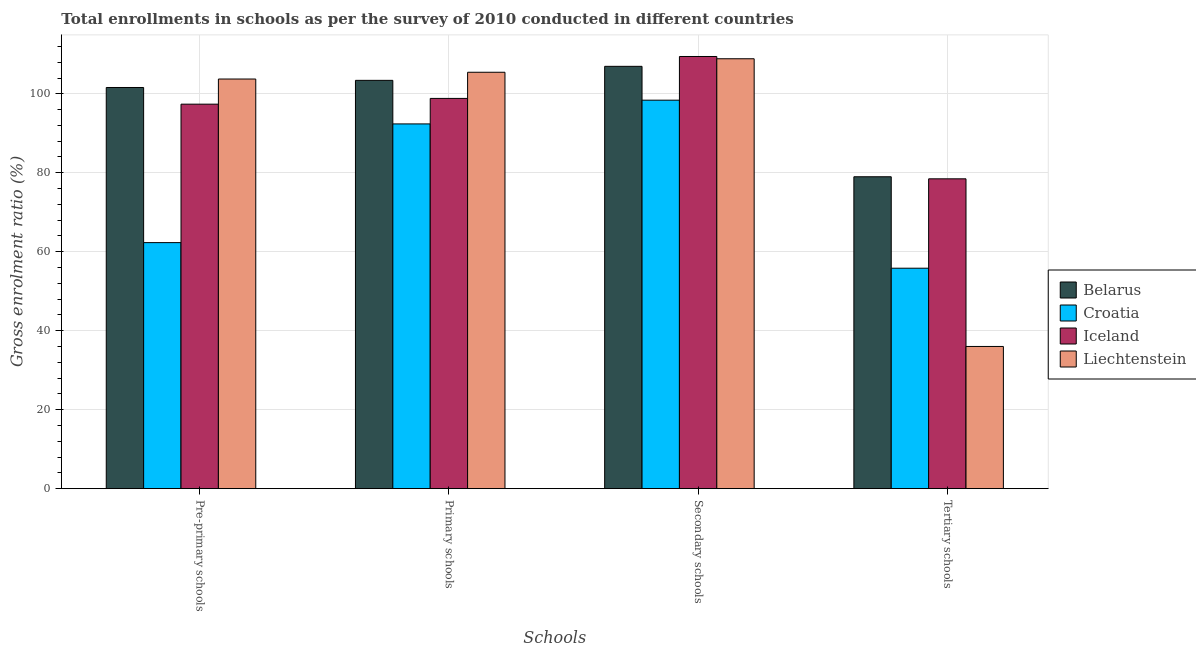Are the number of bars per tick equal to the number of legend labels?
Keep it short and to the point. Yes. Are the number of bars on each tick of the X-axis equal?
Give a very brief answer. Yes. How many bars are there on the 2nd tick from the left?
Make the answer very short. 4. What is the label of the 2nd group of bars from the left?
Give a very brief answer. Primary schools. What is the gross enrolment ratio in tertiary schools in Belarus?
Keep it short and to the point. 78.99. Across all countries, what is the maximum gross enrolment ratio in pre-primary schools?
Provide a short and direct response. 103.74. Across all countries, what is the minimum gross enrolment ratio in pre-primary schools?
Your response must be concise. 62.31. In which country was the gross enrolment ratio in primary schools maximum?
Ensure brevity in your answer.  Liechtenstein. In which country was the gross enrolment ratio in pre-primary schools minimum?
Offer a very short reply. Croatia. What is the total gross enrolment ratio in pre-primary schools in the graph?
Your answer should be compact. 365.04. What is the difference between the gross enrolment ratio in tertiary schools in Croatia and that in Belarus?
Your response must be concise. -23.16. What is the difference between the gross enrolment ratio in pre-primary schools in Croatia and the gross enrolment ratio in primary schools in Belarus?
Offer a terse response. -41.09. What is the average gross enrolment ratio in primary schools per country?
Give a very brief answer. 100.02. What is the difference between the gross enrolment ratio in secondary schools and gross enrolment ratio in pre-primary schools in Liechtenstein?
Offer a terse response. 5.13. What is the ratio of the gross enrolment ratio in pre-primary schools in Iceland to that in Croatia?
Offer a very short reply. 1.56. Is the difference between the gross enrolment ratio in secondary schools in Iceland and Liechtenstein greater than the difference between the gross enrolment ratio in primary schools in Iceland and Liechtenstein?
Offer a very short reply. Yes. What is the difference between the highest and the second highest gross enrolment ratio in tertiary schools?
Provide a succinct answer. 0.52. What is the difference between the highest and the lowest gross enrolment ratio in primary schools?
Offer a terse response. 13.08. In how many countries, is the gross enrolment ratio in primary schools greater than the average gross enrolment ratio in primary schools taken over all countries?
Offer a very short reply. 2. Is the sum of the gross enrolment ratio in primary schools in Belarus and Croatia greater than the maximum gross enrolment ratio in pre-primary schools across all countries?
Your answer should be compact. Yes. Is it the case that in every country, the sum of the gross enrolment ratio in secondary schools and gross enrolment ratio in primary schools is greater than the sum of gross enrolment ratio in pre-primary schools and gross enrolment ratio in tertiary schools?
Offer a terse response. No. What does the 1st bar from the left in Secondary schools represents?
Ensure brevity in your answer.  Belarus. How many bars are there?
Provide a succinct answer. 16. Are all the bars in the graph horizontal?
Offer a terse response. No. How many countries are there in the graph?
Ensure brevity in your answer.  4. Are the values on the major ticks of Y-axis written in scientific E-notation?
Your response must be concise. No. Does the graph contain grids?
Offer a very short reply. Yes. Where does the legend appear in the graph?
Keep it short and to the point. Center right. How many legend labels are there?
Offer a terse response. 4. How are the legend labels stacked?
Your answer should be compact. Vertical. What is the title of the graph?
Give a very brief answer. Total enrollments in schools as per the survey of 2010 conducted in different countries. Does "Latin America(all income levels)" appear as one of the legend labels in the graph?
Your response must be concise. No. What is the label or title of the X-axis?
Your response must be concise. Schools. What is the label or title of the Y-axis?
Ensure brevity in your answer.  Gross enrolment ratio (%). What is the Gross enrolment ratio (%) in Belarus in Pre-primary schools?
Offer a very short reply. 101.6. What is the Gross enrolment ratio (%) in Croatia in Pre-primary schools?
Provide a succinct answer. 62.31. What is the Gross enrolment ratio (%) in Iceland in Pre-primary schools?
Make the answer very short. 97.38. What is the Gross enrolment ratio (%) in Liechtenstein in Pre-primary schools?
Make the answer very short. 103.74. What is the Gross enrolment ratio (%) in Belarus in Primary schools?
Your response must be concise. 103.41. What is the Gross enrolment ratio (%) in Croatia in Primary schools?
Your answer should be compact. 92.38. What is the Gross enrolment ratio (%) in Iceland in Primary schools?
Your answer should be compact. 98.84. What is the Gross enrolment ratio (%) in Liechtenstein in Primary schools?
Offer a terse response. 105.46. What is the Gross enrolment ratio (%) in Belarus in Secondary schools?
Give a very brief answer. 106.96. What is the Gross enrolment ratio (%) of Croatia in Secondary schools?
Ensure brevity in your answer.  98.39. What is the Gross enrolment ratio (%) of Iceland in Secondary schools?
Make the answer very short. 109.45. What is the Gross enrolment ratio (%) in Liechtenstein in Secondary schools?
Offer a very short reply. 108.88. What is the Gross enrolment ratio (%) in Belarus in Tertiary schools?
Keep it short and to the point. 78.99. What is the Gross enrolment ratio (%) in Croatia in Tertiary schools?
Provide a succinct answer. 55.83. What is the Gross enrolment ratio (%) in Iceland in Tertiary schools?
Your response must be concise. 78.47. What is the Gross enrolment ratio (%) in Liechtenstein in Tertiary schools?
Offer a terse response. 36.02. Across all Schools, what is the maximum Gross enrolment ratio (%) in Belarus?
Your answer should be compact. 106.96. Across all Schools, what is the maximum Gross enrolment ratio (%) of Croatia?
Ensure brevity in your answer.  98.39. Across all Schools, what is the maximum Gross enrolment ratio (%) of Iceland?
Make the answer very short. 109.45. Across all Schools, what is the maximum Gross enrolment ratio (%) in Liechtenstein?
Your answer should be compact. 108.88. Across all Schools, what is the minimum Gross enrolment ratio (%) of Belarus?
Make the answer very short. 78.99. Across all Schools, what is the minimum Gross enrolment ratio (%) in Croatia?
Keep it short and to the point. 55.83. Across all Schools, what is the minimum Gross enrolment ratio (%) in Iceland?
Provide a succinct answer. 78.47. Across all Schools, what is the minimum Gross enrolment ratio (%) of Liechtenstein?
Provide a succinct answer. 36.02. What is the total Gross enrolment ratio (%) in Belarus in the graph?
Ensure brevity in your answer.  390.96. What is the total Gross enrolment ratio (%) of Croatia in the graph?
Ensure brevity in your answer.  308.91. What is the total Gross enrolment ratio (%) of Iceland in the graph?
Your response must be concise. 384.14. What is the total Gross enrolment ratio (%) of Liechtenstein in the graph?
Your response must be concise. 354.1. What is the difference between the Gross enrolment ratio (%) in Belarus in Pre-primary schools and that in Primary schools?
Offer a terse response. -1.81. What is the difference between the Gross enrolment ratio (%) of Croatia in Pre-primary schools and that in Primary schools?
Your response must be concise. -30.06. What is the difference between the Gross enrolment ratio (%) of Iceland in Pre-primary schools and that in Primary schools?
Make the answer very short. -1.46. What is the difference between the Gross enrolment ratio (%) of Liechtenstein in Pre-primary schools and that in Primary schools?
Your response must be concise. -1.71. What is the difference between the Gross enrolment ratio (%) of Belarus in Pre-primary schools and that in Secondary schools?
Provide a succinct answer. -5.36. What is the difference between the Gross enrolment ratio (%) of Croatia in Pre-primary schools and that in Secondary schools?
Your answer should be compact. -36.07. What is the difference between the Gross enrolment ratio (%) in Iceland in Pre-primary schools and that in Secondary schools?
Provide a succinct answer. -12.08. What is the difference between the Gross enrolment ratio (%) in Liechtenstein in Pre-primary schools and that in Secondary schools?
Give a very brief answer. -5.13. What is the difference between the Gross enrolment ratio (%) in Belarus in Pre-primary schools and that in Tertiary schools?
Provide a succinct answer. 22.61. What is the difference between the Gross enrolment ratio (%) of Croatia in Pre-primary schools and that in Tertiary schools?
Your response must be concise. 6.48. What is the difference between the Gross enrolment ratio (%) of Iceland in Pre-primary schools and that in Tertiary schools?
Your response must be concise. 18.91. What is the difference between the Gross enrolment ratio (%) in Liechtenstein in Pre-primary schools and that in Tertiary schools?
Provide a succinct answer. 67.73. What is the difference between the Gross enrolment ratio (%) of Belarus in Primary schools and that in Secondary schools?
Give a very brief answer. -3.55. What is the difference between the Gross enrolment ratio (%) in Croatia in Primary schools and that in Secondary schools?
Offer a very short reply. -6.01. What is the difference between the Gross enrolment ratio (%) of Iceland in Primary schools and that in Secondary schools?
Make the answer very short. -10.62. What is the difference between the Gross enrolment ratio (%) in Liechtenstein in Primary schools and that in Secondary schools?
Offer a terse response. -3.42. What is the difference between the Gross enrolment ratio (%) in Belarus in Primary schools and that in Tertiary schools?
Your answer should be compact. 24.41. What is the difference between the Gross enrolment ratio (%) of Croatia in Primary schools and that in Tertiary schools?
Offer a very short reply. 36.54. What is the difference between the Gross enrolment ratio (%) of Iceland in Primary schools and that in Tertiary schools?
Your answer should be compact. 20.36. What is the difference between the Gross enrolment ratio (%) in Liechtenstein in Primary schools and that in Tertiary schools?
Your response must be concise. 69.44. What is the difference between the Gross enrolment ratio (%) of Belarus in Secondary schools and that in Tertiary schools?
Make the answer very short. 27.97. What is the difference between the Gross enrolment ratio (%) of Croatia in Secondary schools and that in Tertiary schools?
Offer a very short reply. 42.55. What is the difference between the Gross enrolment ratio (%) of Iceland in Secondary schools and that in Tertiary schools?
Offer a terse response. 30.98. What is the difference between the Gross enrolment ratio (%) of Liechtenstein in Secondary schools and that in Tertiary schools?
Offer a terse response. 72.86. What is the difference between the Gross enrolment ratio (%) in Belarus in Pre-primary schools and the Gross enrolment ratio (%) in Croatia in Primary schools?
Your response must be concise. 9.22. What is the difference between the Gross enrolment ratio (%) in Belarus in Pre-primary schools and the Gross enrolment ratio (%) in Iceland in Primary schools?
Your answer should be very brief. 2.76. What is the difference between the Gross enrolment ratio (%) in Belarus in Pre-primary schools and the Gross enrolment ratio (%) in Liechtenstein in Primary schools?
Offer a terse response. -3.86. What is the difference between the Gross enrolment ratio (%) of Croatia in Pre-primary schools and the Gross enrolment ratio (%) of Iceland in Primary schools?
Offer a very short reply. -36.52. What is the difference between the Gross enrolment ratio (%) of Croatia in Pre-primary schools and the Gross enrolment ratio (%) of Liechtenstein in Primary schools?
Keep it short and to the point. -43.15. What is the difference between the Gross enrolment ratio (%) of Iceland in Pre-primary schools and the Gross enrolment ratio (%) of Liechtenstein in Primary schools?
Ensure brevity in your answer.  -8.08. What is the difference between the Gross enrolment ratio (%) of Belarus in Pre-primary schools and the Gross enrolment ratio (%) of Croatia in Secondary schools?
Keep it short and to the point. 3.21. What is the difference between the Gross enrolment ratio (%) in Belarus in Pre-primary schools and the Gross enrolment ratio (%) in Iceland in Secondary schools?
Your response must be concise. -7.85. What is the difference between the Gross enrolment ratio (%) of Belarus in Pre-primary schools and the Gross enrolment ratio (%) of Liechtenstein in Secondary schools?
Keep it short and to the point. -7.28. What is the difference between the Gross enrolment ratio (%) in Croatia in Pre-primary schools and the Gross enrolment ratio (%) in Iceland in Secondary schools?
Your response must be concise. -47.14. What is the difference between the Gross enrolment ratio (%) in Croatia in Pre-primary schools and the Gross enrolment ratio (%) in Liechtenstein in Secondary schools?
Ensure brevity in your answer.  -46.57. What is the difference between the Gross enrolment ratio (%) of Iceland in Pre-primary schools and the Gross enrolment ratio (%) of Liechtenstein in Secondary schools?
Provide a short and direct response. -11.5. What is the difference between the Gross enrolment ratio (%) of Belarus in Pre-primary schools and the Gross enrolment ratio (%) of Croatia in Tertiary schools?
Your response must be concise. 45.77. What is the difference between the Gross enrolment ratio (%) in Belarus in Pre-primary schools and the Gross enrolment ratio (%) in Iceland in Tertiary schools?
Keep it short and to the point. 23.13. What is the difference between the Gross enrolment ratio (%) of Belarus in Pre-primary schools and the Gross enrolment ratio (%) of Liechtenstein in Tertiary schools?
Ensure brevity in your answer.  65.58. What is the difference between the Gross enrolment ratio (%) in Croatia in Pre-primary schools and the Gross enrolment ratio (%) in Iceland in Tertiary schools?
Offer a terse response. -16.16. What is the difference between the Gross enrolment ratio (%) in Croatia in Pre-primary schools and the Gross enrolment ratio (%) in Liechtenstein in Tertiary schools?
Make the answer very short. 26.3. What is the difference between the Gross enrolment ratio (%) of Iceland in Pre-primary schools and the Gross enrolment ratio (%) of Liechtenstein in Tertiary schools?
Your answer should be very brief. 61.36. What is the difference between the Gross enrolment ratio (%) of Belarus in Primary schools and the Gross enrolment ratio (%) of Croatia in Secondary schools?
Make the answer very short. 5.02. What is the difference between the Gross enrolment ratio (%) in Belarus in Primary schools and the Gross enrolment ratio (%) in Iceland in Secondary schools?
Give a very brief answer. -6.05. What is the difference between the Gross enrolment ratio (%) in Belarus in Primary schools and the Gross enrolment ratio (%) in Liechtenstein in Secondary schools?
Keep it short and to the point. -5.47. What is the difference between the Gross enrolment ratio (%) of Croatia in Primary schools and the Gross enrolment ratio (%) of Iceland in Secondary schools?
Offer a terse response. -17.08. What is the difference between the Gross enrolment ratio (%) in Croatia in Primary schools and the Gross enrolment ratio (%) in Liechtenstein in Secondary schools?
Your answer should be very brief. -16.5. What is the difference between the Gross enrolment ratio (%) in Iceland in Primary schools and the Gross enrolment ratio (%) in Liechtenstein in Secondary schools?
Give a very brief answer. -10.04. What is the difference between the Gross enrolment ratio (%) of Belarus in Primary schools and the Gross enrolment ratio (%) of Croatia in Tertiary schools?
Your answer should be very brief. 47.57. What is the difference between the Gross enrolment ratio (%) of Belarus in Primary schools and the Gross enrolment ratio (%) of Iceland in Tertiary schools?
Offer a very short reply. 24.94. What is the difference between the Gross enrolment ratio (%) of Belarus in Primary schools and the Gross enrolment ratio (%) of Liechtenstein in Tertiary schools?
Make the answer very short. 67.39. What is the difference between the Gross enrolment ratio (%) in Croatia in Primary schools and the Gross enrolment ratio (%) in Iceland in Tertiary schools?
Offer a terse response. 13.9. What is the difference between the Gross enrolment ratio (%) of Croatia in Primary schools and the Gross enrolment ratio (%) of Liechtenstein in Tertiary schools?
Your answer should be compact. 56.36. What is the difference between the Gross enrolment ratio (%) of Iceland in Primary schools and the Gross enrolment ratio (%) of Liechtenstein in Tertiary schools?
Make the answer very short. 62.82. What is the difference between the Gross enrolment ratio (%) in Belarus in Secondary schools and the Gross enrolment ratio (%) in Croatia in Tertiary schools?
Provide a succinct answer. 51.13. What is the difference between the Gross enrolment ratio (%) of Belarus in Secondary schools and the Gross enrolment ratio (%) of Iceland in Tertiary schools?
Your answer should be compact. 28.49. What is the difference between the Gross enrolment ratio (%) of Belarus in Secondary schools and the Gross enrolment ratio (%) of Liechtenstein in Tertiary schools?
Keep it short and to the point. 70.94. What is the difference between the Gross enrolment ratio (%) in Croatia in Secondary schools and the Gross enrolment ratio (%) in Iceland in Tertiary schools?
Your answer should be compact. 19.92. What is the difference between the Gross enrolment ratio (%) of Croatia in Secondary schools and the Gross enrolment ratio (%) of Liechtenstein in Tertiary schools?
Your answer should be very brief. 62.37. What is the difference between the Gross enrolment ratio (%) of Iceland in Secondary schools and the Gross enrolment ratio (%) of Liechtenstein in Tertiary schools?
Your answer should be very brief. 73.44. What is the average Gross enrolment ratio (%) in Belarus per Schools?
Your answer should be compact. 97.74. What is the average Gross enrolment ratio (%) of Croatia per Schools?
Make the answer very short. 77.23. What is the average Gross enrolment ratio (%) of Iceland per Schools?
Provide a short and direct response. 96.04. What is the average Gross enrolment ratio (%) of Liechtenstein per Schools?
Offer a terse response. 88.53. What is the difference between the Gross enrolment ratio (%) in Belarus and Gross enrolment ratio (%) in Croatia in Pre-primary schools?
Offer a terse response. 39.29. What is the difference between the Gross enrolment ratio (%) in Belarus and Gross enrolment ratio (%) in Iceland in Pre-primary schools?
Make the answer very short. 4.22. What is the difference between the Gross enrolment ratio (%) of Belarus and Gross enrolment ratio (%) of Liechtenstein in Pre-primary schools?
Your response must be concise. -2.14. What is the difference between the Gross enrolment ratio (%) in Croatia and Gross enrolment ratio (%) in Iceland in Pre-primary schools?
Offer a very short reply. -35.06. What is the difference between the Gross enrolment ratio (%) in Croatia and Gross enrolment ratio (%) in Liechtenstein in Pre-primary schools?
Your answer should be very brief. -41.43. What is the difference between the Gross enrolment ratio (%) in Iceland and Gross enrolment ratio (%) in Liechtenstein in Pre-primary schools?
Provide a succinct answer. -6.37. What is the difference between the Gross enrolment ratio (%) in Belarus and Gross enrolment ratio (%) in Croatia in Primary schools?
Offer a very short reply. 11.03. What is the difference between the Gross enrolment ratio (%) of Belarus and Gross enrolment ratio (%) of Iceland in Primary schools?
Offer a very short reply. 4.57. What is the difference between the Gross enrolment ratio (%) in Belarus and Gross enrolment ratio (%) in Liechtenstein in Primary schools?
Your response must be concise. -2.05. What is the difference between the Gross enrolment ratio (%) of Croatia and Gross enrolment ratio (%) of Iceland in Primary schools?
Provide a short and direct response. -6.46. What is the difference between the Gross enrolment ratio (%) of Croatia and Gross enrolment ratio (%) of Liechtenstein in Primary schools?
Provide a short and direct response. -13.08. What is the difference between the Gross enrolment ratio (%) of Iceland and Gross enrolment ratio (%) of Liechtenstein in Primary schools?
Your answer should be compact. -6.62. What is the difference between the Gross enrolment ratio (%) in Belarus and Gross enrolment ratio (%) in Croatia in Secondary schools?
Your answer should be very brief. 8.57. What is the difference between the Gross enrolment ratio (%) of Belarus and Gross enrolment ratio (%) of Iceland in Secondary schools?
Give a very brief answer. -2.49. What is the difference between the Gross enrolment ratio (%) of Belarus and Gross enrolment ratio (%) of Liechtenstein in Secondary schools?
Offer a terse response. -1.92. What is the difference between the Gross enrolment ratio (%) of Croatia and Gross enrolment ratio (%) of Iceland in Secondary schools?
Your answer should be very brief. -11.07. What is the difference between the Gross enrolment ratio (%) in Croatia and Gross enrolment ratio (%) in Liechtenstein in Secondary schools?
Ensure brevity in your answer.  -10.49. What is the difference between the Gross enrolment ratio (%) in Iceland and Gross enrolment ratio (%) in Liechtenstein in Secondary schools?
Offer a very short reply. 0.57. What is the difference between the Gross enrolment ratio (%) in Belarus and Gross enrolment ratio (%) in Croatia in Tertiary schools?
Keep it short and to the point. 23.16. What is the difference between the Gross enrolment ratio (%) of Belarus and Gross enrolment ratio (%) of Iceland in Tertiary schools?
Your answer should be very brief. 0.52. What is the difference between the Gross enrolment ratio (%) of Belarus and Gross enrolment ratio (%) of Liechtenstein in Tertiary schools?
Your answer should be compact. 42.98. What is the difference between the Gross enrolment ratio (%) in Croatia and Gross enrolment ratio (%) in Iceland in Tertiary schools?
Offer a terse response. -22.64. What is the difference between the Gross enrolment ratio (%) of Croatia and Gross enrolment ratio (%) of Liechtenstein in Tertiary schools?
Provide a short and direct response. 19.82. What is the difference between the Gross enrolment ratio (%) of Iceland and Gross enrolment ratio (%) of Liechtenstein in Tertiary schools?
Your answer should be very brief. 42.45. What is the ratio of the Gross enrolment ratio (%) of Belarus in Pre-primary schools to that in Primary schools?
Provide a succinct answer. 0.98. What is the ratio of the Gross enrolment ratio (%) of Croatia in Pre-primary schools to that in Primary schools?
Make the answer very short. 0.67. What is the ratio of the Gross enrolment ratio (%) in Iceland in Pre-primary schools to that in Primary schools?
Keep it short and to the point. 0.99. What is the ratio of the Gross enrolment ratio (%) of Liechtenstein in Pre-primary schools to that in Primary schools?
Your answer should be compact. 0.98. What is the ratio of the Gross enrolment ratio (%) of Belarus in Pre-primary schools to that in Secondary schools?
Give a very brief answer. 0.95. What is the ratio of the Gross enrolment ratio (%) in Croatia in Pre-primary schools to that in Secondary schools?
Provide a short and direct response. 0.63. What is the ratio of the Gross enrolment ratio (%) of Iceland in Pre-primary schools to that in Secondary schools?
Offer a very short reply. 0.89. What is the ratio of the Gross enrolment ratio (%) in Liechtenstein in Pre-primary schools to that in Secondary schools?
Offer a very short reply. 0.95. What is the ratio of the Gross enrolment ratio (%) in Belarus in Pre-primary schools to that in Tertiary schools?
Your answer should be compact. 1.29. What is the ratio of the Gross enrolment ratio (%) of Croatia in Pre-primary schools to that in Tertiary schools?
Give a very brief answer. 1.12. What is the ratio of the Gross enrolment ratio (%) of Iceland in Pre-primary schools to that in Tertiary schools?
Offer a very short reply. 1.24. What is the ratio of the Gross enrolment ratio (%) of Liechtenstein in Pre-primary schools to that in Tertiary schools?
Provide a succinct answer. 2.88. What is the ratio of the Gross enrolment ratio (%) of Belarus in Primary schools to that in Secondary schools?
Make the answer very short. 0.97. What is the ratio of the Gross enrolment ratio (%) in Croatia in Primary schools to that in Secondary schools?
Provide a short and direct response. 0.94. What is the ratio of the Gross enrolment ratio (%) in Iceland in Primary schools to that in Secondary schools?
Keep it short and to the point. 0.9. What is the ratio of the Gross enrolment ratio (%) of Liechtenstein in Primary schools to that in Secondary schools?
Give a very brief answer. 0.97. What is the ratio of the Gross enrolment ratio (%) in Belarus in Primary schools to that in Tertiary schools?
Provide a succinct answer. 1.31. What is the ratio of the Gross enrolment ratio (%) of Croatia in Primary schools to that in Tertiary schools?
Offer a terse response. 1.65. What is the ratio of the Gross enrolment ratio (%) in Iceland in Primary schools to that in Tertiary schools?
Offer a terse response. 1.26. What is the ratio of the Gross enrolment ratio (%) in Liechtenstein in Primary schools to that in Tertiary schools?
Provide a succinct answer. 2.93. What is the ratio of the Gross enrolment ratio (%) in Belarus in Secondary schools to that in Tertiary schools?
Provide a succinct answer. 1.35. What is the ratio of the Gross enrolment ratio (%) of Croatia in Secondary schools to that in Tertiary schools?
Your response must be concise. 1.76. What is the ratio of the Gross enrolment ratio (%) of Iceland in Secondary schools to that in Tertiary schools?
Ensure brevity in your answer.  1.39. What is the ratio of the Gross enrolment ratio (%) in Liechtenstein in Secondary schools to that in Tertiary schools?
Ensure brevity in your answer.  3.02. What is the difference between the highest and the second highest Gross enrolment ratio (%) in Belarus?
Your answer should be compact. 3.55. What is the difference between the highest and the second highest Gross enrolment ratio (%) in Croatia?
Your answer should be compact. 6.01. What is the difference between the highest and the second highest Gross enrolment ratio (%) in Iceland?
Ensure brevity in your answer.  10.62. What is the difference between the highest and the second highest Gross enrolment ratio (%) of Liechtenstein?
Your response must be concise. 3.42. What is the difference between the highest and the lowest Gross enrolment ratio (%) in Belarus?
Offer a terse response. 27.97. What is the difference between the highest and the lowest Gross enrolment ratio (%) in Croatia?
Keep it short and to the point. 42.55. What is the difference between the highest and the lowest Gross enrolment ratio (%) of Iceland?
Offer a very short reply. 30.98. What is the difference between the highest and the lowest Gross enrolment ratio (%) in Liechtenstein?
Provide a succinct answer. 72.86. 